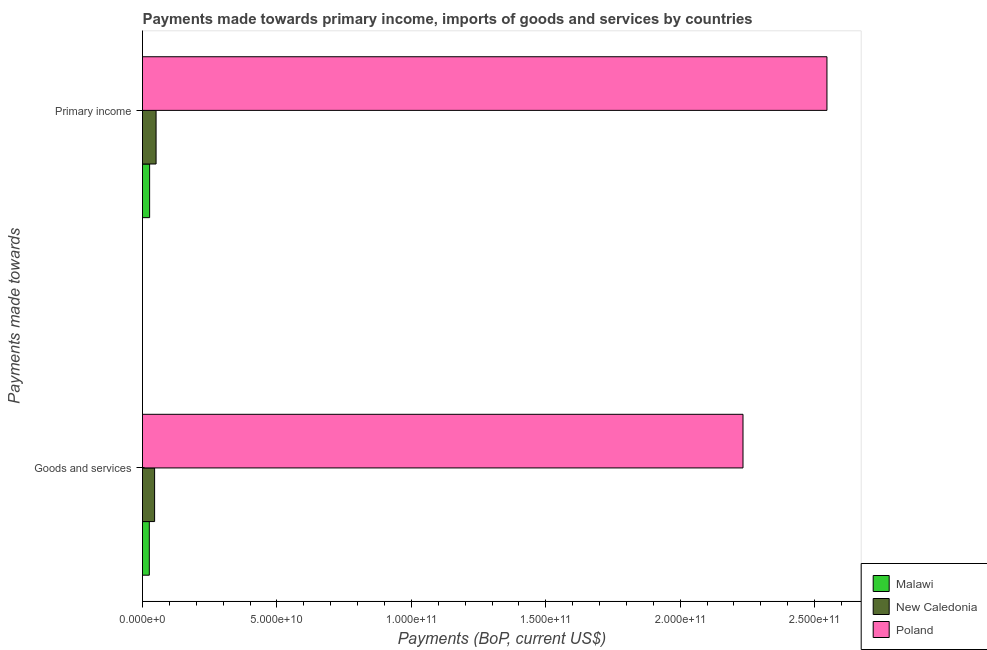Are the number of bars on each tick of the Y-axis equal?
Offer a terse response. Yes. What is the label of the 2nd group of bars from the top?
Your response must be concise. Goods and services. What is the payments made towards goods and services in Poland?
Your answer should be very brief. 2.23e+11. Across all countries, what is the maximum payments made towards goods and services?
Offer a terse response. 2.23e+11. Across all countries, what is the minimum payments made towards goods and services?
Offer a very short reply. 2.53e+09. In which country was the payments made towards primary income minimum?
Provide a succinct answer. Malawi. What is the total payments made towards primary income in the graph?
Make the answer very short. 2.62e+11. What is the difference between the payments made towards goods and services in Malawi and that in Poland?
Give a very brief answer. -2.21e+11. What is the difference between the payments made towards primary income in Poland and the payments made towards goods and services in Malawi?
Provide a short and direct response. 2.52e+11. What is the average payments made towards primary income per country?
Your answer should be compact. 8.74e+1. What is the difference between the payments made towards primary income and payments made towards goods and services in Malawi?
Your answer should be compact. 1.14e+08. What is the ratio of the payments made towards primary income in New Caledonia to that in Malawi?
Your answer should be very brief. 1.91. What does the 2nd bar from the top in Primary income represents?
Make the answer very short. New Caledonia. What does the 1st bar from the bottom in Primary income represents?
Provide a short and direct response. Malawi. How many bars are there?
Your response must be concise. 6. What is the difference between two consecutive major ticks on the X-axis?
Your answer should be compact. 5.00e+1. Are the values on the major ticks of X-axis written in scientific E-notation?
Your answer should be compact. Yes. Where does the legend appear in the graph?
Keep it short and to the point. Bottom right. How are the legend labels stacked?
Your answer should be compact. Vertical. What is the title of the graph?
Make the answer very short. Payments made towards primary income, imports of goods and services by countries. What is the label or title of the X-axis?
Your response must be concise. Payments (BoP, current US$). What is the label or title of the Y-axis?
Keep it short and to the point. Payments made towards. What is the Payments (BoP, current US$) of Malawi in Goods and services?
Make the answer very short. 2.53e+09. What is the Payments (BoP, current US$) in New Caledonia in Goods and services?
Offer a terse response. 4.50e+09. What is the Payments (BoP, current US$) of Poland in Goods and services?
Your answer should be very brief. 2.23e+11. What is the Payments (BoP, current US$) of Malawi in Primary income?
Offer a very short reply. 2.65e+09. What is the Payments (BoP, current US$) of New Caledonia in Primary income?
Make the answer very short. 5.05e+09. What is the Payments (BoP, current US$) in Poland in Primary income?
Offer a terse response. 2.55e+11. Across all Payments made towards, what is the maximum Payments (BoP, current US$) of Malawi?
Ensure brevity in your answer.  2.65e+09. Across all Payments made towards, what is the maximum Payments (BoP, current US$) of New Caledonia?
Offer a terse response. 5.05e+09. Across all Payments made towards, what is the maximum Payments (BoP, current US$) in Poland?
Provide a short and direct response. 2.55e+11. Across all Payments made towards, what is the minimum Payments (BoP, current US$) in Malawi?
Keep it short and to the point. 2.53e+09. Across all Payments made towards, what is the minimum Payments (BoP, current US$) of New Caledonia?
Your answer should be compact. 4.50e+09. Across all Payments made towards, what is the minimum Payments (BoP, current US$) in Poland?
Offer a very short reply. 2.23e+11. What is the total Payments (BoP, current US$) of Malawi in the graph?
Your response must be concise. 5.18e+09. What is the total Payments (BoP, current US$) in New Caledonia in the graph?
Make the answer very short. 9.56e+09. What is the total Payments (BoP, current US$) of Poland in the graph?
Your answer should be compact. 4.78e+11. What is the difference between the Payments (BoP, current US$) of Malawi in Goods and services and that in Primary income?
Keep it short and to the point. -1.14e+08. What is the difference between the Payments (BoP, current US$) of New Caledonia in Goods and services and that in Primary income?
Ensure brevity in your answer.  -5.46e+08. What is the difference between the Payments (BoP, current US$) of Poland in Goods and services and that in Primary income?
Keep it short and to the point. -3.12e+1. What is the difference between the Payments (BoP, current US$) of Malawi in Goods and services and the Payments (BoP, current US$) of New Caledonia in Primary income?
Provide a succinct answer. -2.52e+09. What is the difference between the Payments (BoP, current US$) of Malawi in Goods and services and the Payments (BoP, current US$) of Poland in Primary income?
Your answer should be very brief. -2.52e+11. What is the difference between the Payments (BoP, current US$) in New Caledonia in Goods and services and the Payments (BoP, current US$) in Poland in Primary income?
Provide a succinct answer. -2.50e+11. What is the average Payments (BoP, current US$) of Malawi per Payments made towards?
Provide a succinct answer. 2.59e+09. What is the average Payments (BoP, current US$) of New Caledonia per Payments made towards?
Ensure brevity in your answer.  4.78e+09. What is the average Payments (BoP, current US$) of Poland per Payments made towards?
Your answer should be very brief. 2.39e+11. What is the difference between the Payments (BoP, current US$) in Malawi and Payments (BoP, current US$) in New Caledonia in Goods and services?
Provide a short and direct response. -1.97e+09. What is the difference between the Payments (BoP, current US$) of Malawi and Payments (BoP, current US$) of Poland in Goods and services?
Make the answer very short. -2.21e+11. What is the difference between the Payments (BoP, current US$) in New Caledonia and Payments (BoP, current US$) in Poland in Goods and services?
Ensure brevity in your answer.  -2.19e+11. What is the difference between the Payments (BoP, current US$) of Malawi and Payments (BoP, current US$) of New Caledonia in Primary income?
Offer a very short reply. -2.40e+09. What is the difference between the Payments (BoP, current US$) of Malawi and Payments (BoP, current US$) of Poland in Primary income?
Make the answer very short. -2.52e+11. What is the difference between the Payments (BoP, current US$) of New Caledonia and Payments (BoP, current US$) of Poland in Primary income?
Your answer should be very brief. -2.50e+11. What is the ratio of the Payments (BoP, current US$) of Malawi in Goods and services to that in Primary income?
Make the answer very short. 0.96. What is the ratio of the Payments (BoP, current US$) of New Caledonia in Goods and services to that in Primary income?
Give a very brief answer. 0.89. What is the ratio of the Payments (BoP, current US$) of Poland in Goods and services to that in Primary income?
Offer a very short reply. 0.88. What is the difference between the highest and the second highest Payments (BoP, current US$) in Malawi?
Your answer should be compact. 1.14e+08. What is the difference between the highest and the second highest Payments (BoP, current US$) of New Caledonia?
Ensure brevity in your answer.  5.46e+08. What is the difference between the highest and the second highest Payments (BoP, current US$) in Poland?
Provide a short and direct response. 3.12e+1. What is the difference between the highest and the lowest Payments (BoP, current US$) of Malawi?
Give a very brief answer. 1.14e+08. What is the difference between the highest and the lowest Payments (BoP, current US$) of New Caledonia?
Your response must be concise. 5.46e+08. What is the difference between the highest and the lowest Payments (BoP, current US$) of Poland?
Provide a short and direct response. 3.12e+1. 